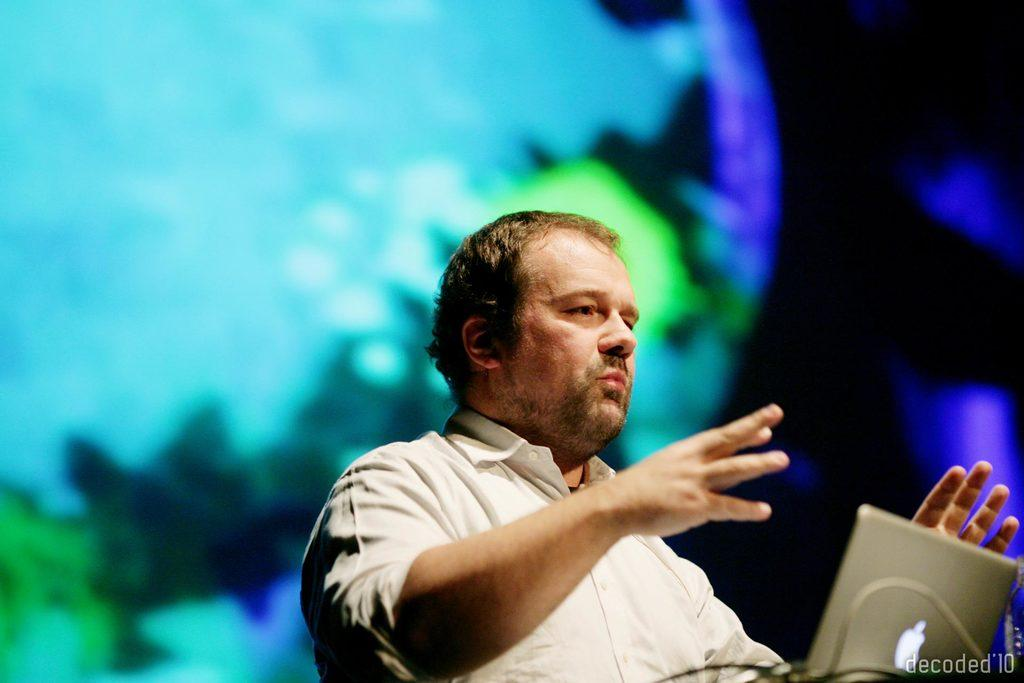What is the man doing in the image? The man is standing in front of a laptop. What is the man wearing in the image? The man is wearing a white color shirt. What colors can be seen in the background of the image? The background of the image has blue, green, and black colors. How many rings are on the man's fingers in the image? There is no information about rings on the man's fingers in the image. What type of pump is visible in the image? There is no pump present in the image. 